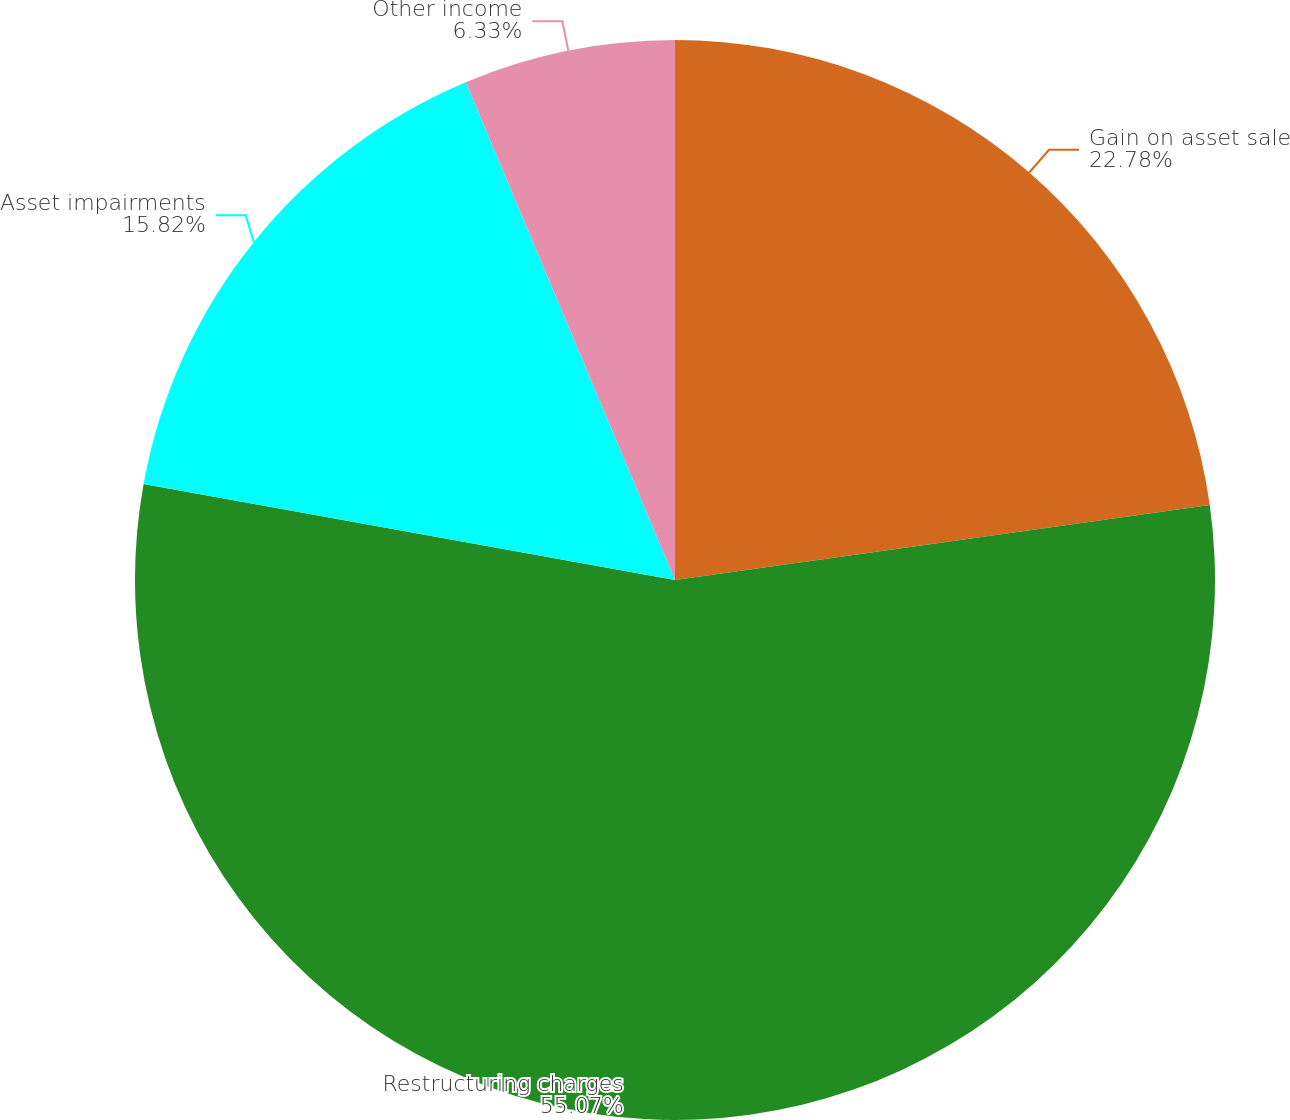<chart> <loc_0><loc_0><loc_500><loc_500><pie_chart><fcel>Gain on asset sale<fcel>Restructuring charges<fcel>Asset impairments<fcel>Other income<nl><fcel>22.78%<fcel>55.06%<fcel>15.82%<fcel>6.33%<nl></chart> 